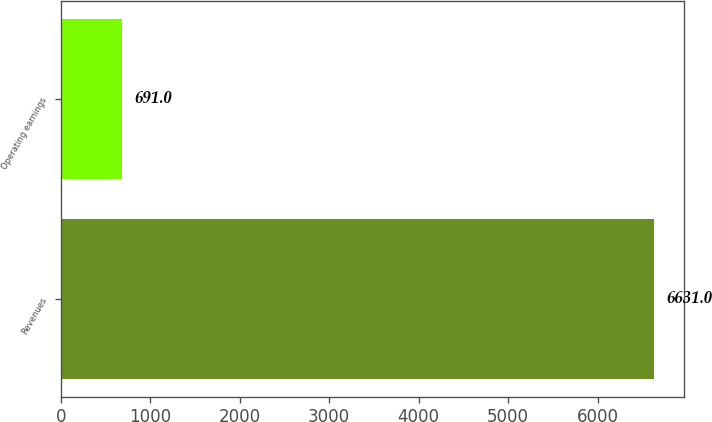Convert chart. <chart><loc_0><loc_0><loc_500><loc_500><bar_chart><fcel>Revenues<fcel>Operating earnings<nl><fcel>6631<fcel>691<nl></chart> 